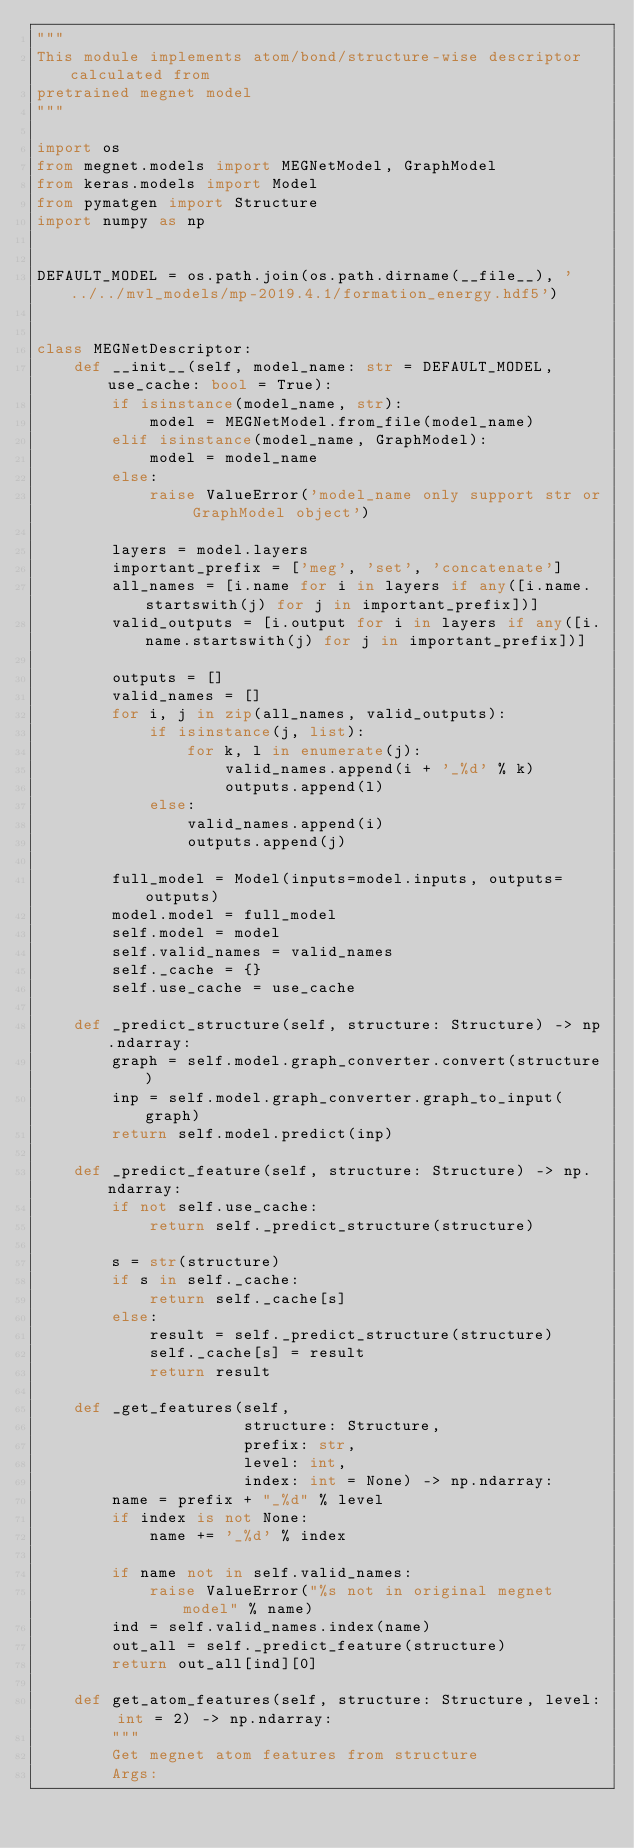<code> <loc_0><loc_0><loc_500><loc_500><_Python_>"""
This module implements atom/bond/structure-wise descriptor calculated from
pretrained megnet model
"""

import os
from megnet.models import MEGNetModel, GraphModel
from keras.models import Model
from pymatgen import Structure
import numpy as np


DEFAULT_MODEL = os.path.join(os.path.dirname(__file__), '../../mvl_models/mp-2019.4.1/formation_energy.hdf5')


class MEGNetDescriptor:
    def __init__(self, model_name: str = DEFAULT_MODEL, use_cache: bool = True):
        if isinstance(model_name, str):
            model = MEGNetModel.from_file(model_name)
        elif isinstance(model_name, GraphModel):
            model = model_name
        else:
            raise ValueError('model_name only support str or GraphModel object')

        layers = model.layers
        important_prefix = ['meg', 'set', 'concatenate']
        all_names = [i.name for i in layers if any([i.name.startswith(j) for j in important_prefix])]
        valid_outputs = [i.output for i in layers if any([i.name.startswith(j) for j in important_prefix])]

        outputs = []
        valid_names = []
        for i, j in zip(all_names, valid_outputs):
            if isinstance(j, list):
                for k, l in enumerate(j):
                    valid_names.append(i + '_%d' % k)
                    outputs.append(l)
            else:
                valid_names.append(i)
                outputs.append(j)

        full_model = Model(inputs=model.inputs, outputs=outputs)
        model.model = full_model
        self.model = model
        self.valid_names = valid_names
        self._cache = {}
        self.use_cache = use_cache

    def _predict_structure(self, structure: Structure) -> np.ndarray:
        graph = self.model.graph_converter.convert(structure)
        inp = self.model.graph_converter.graph_to_input(graph)
        return self.model.predict(inp)

    def _predict_feature(self, structure: Structure) -> np.ndarray:
        if not self.use_cache:
            return self._predict_structure(structure)

        s = str(structure)
        if s in self._cache:
            return self._cache[s]
        else:
            result = self._predict_structure(structure)
            self._cache[s] = result
            return result

    def _get_features(self,
                      structure: Structure,
                      prefix: str,
                      level: int,
                      index: int = None) -> np.ndarray:
        name = prefix + "_%d" % level
        if index is not None:
            name += '_%d' % index

        if name not in self.valid_names:
            raise ValueError("%s not in original megnet model" % name)
        ind = self.valid_names.index(name)
        out_all = self._predict_feature(structure)
        return out_all[ind][0]

    def get_atom_features(self, structure: Structure, level: int = 2) -> np.ndarray:
        """
        Get megnet atom features from structure
        Args:</code> 